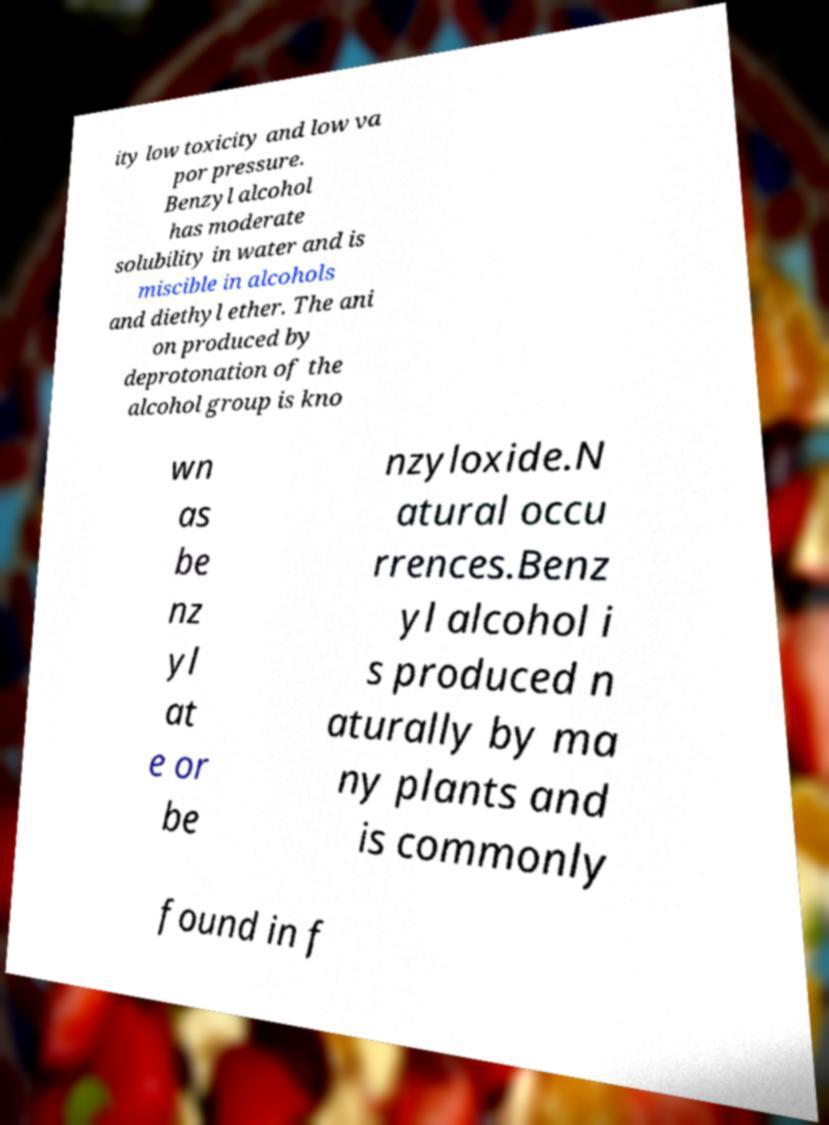For documentation purposes, I need the text within this image transcribed. Could you provide that? ity low toxicity and low va por pressure. Benzyl alcohol has moderate solubility in water and is miscible in alcohols and diethyl ether. The ani on produced by deprotonation of the alcohol group is kno wn as be nz yl at e or be nzyloxide.N atural occu rrences.Benz yl alcohol i s produced n aturally by ma ny plants and is commonly found in f 